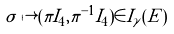<formula> <loc_0><loc_0><loc_500><loc_500>\sigma \mapsto ( \pi I _ { 4 } , \pi ^ { - 1 } I _ { 4 } ) \in I _ { \gamma } ( E )</formula> 